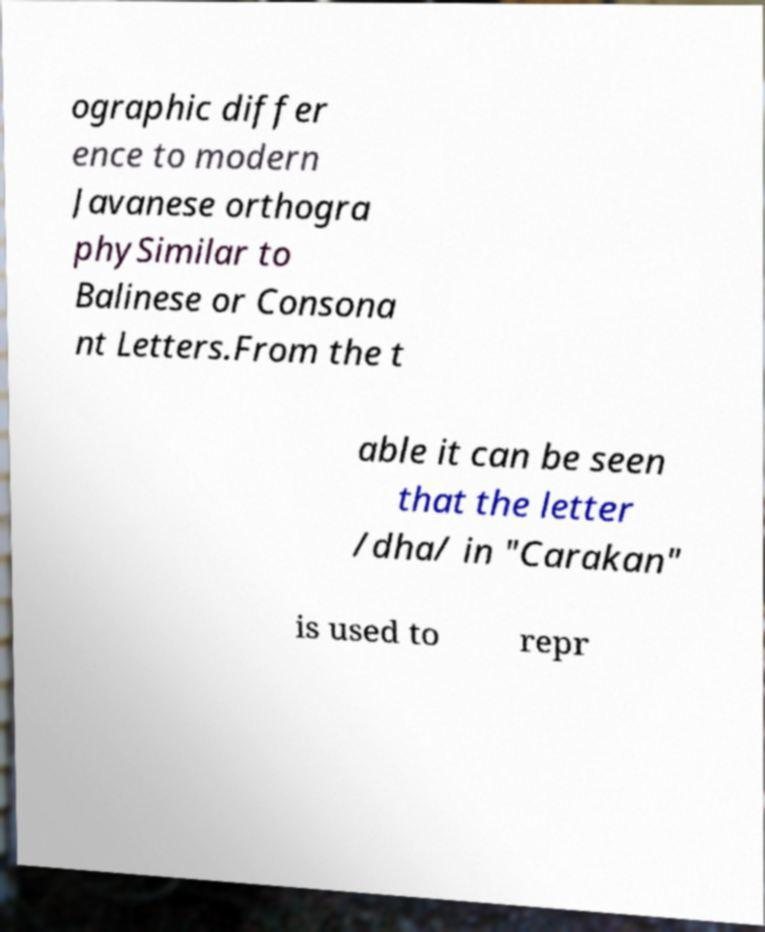Can you read and provide the text displayed in the image?This photo seems to have some interesting text. Can you extract and type it out for me? ographic differ ence to modern Javanese orthogra phySimilar to Balinese or Consona nt Letters.From the t able it can be seen that the letter /dha/ in "Carakan" is used to repr 